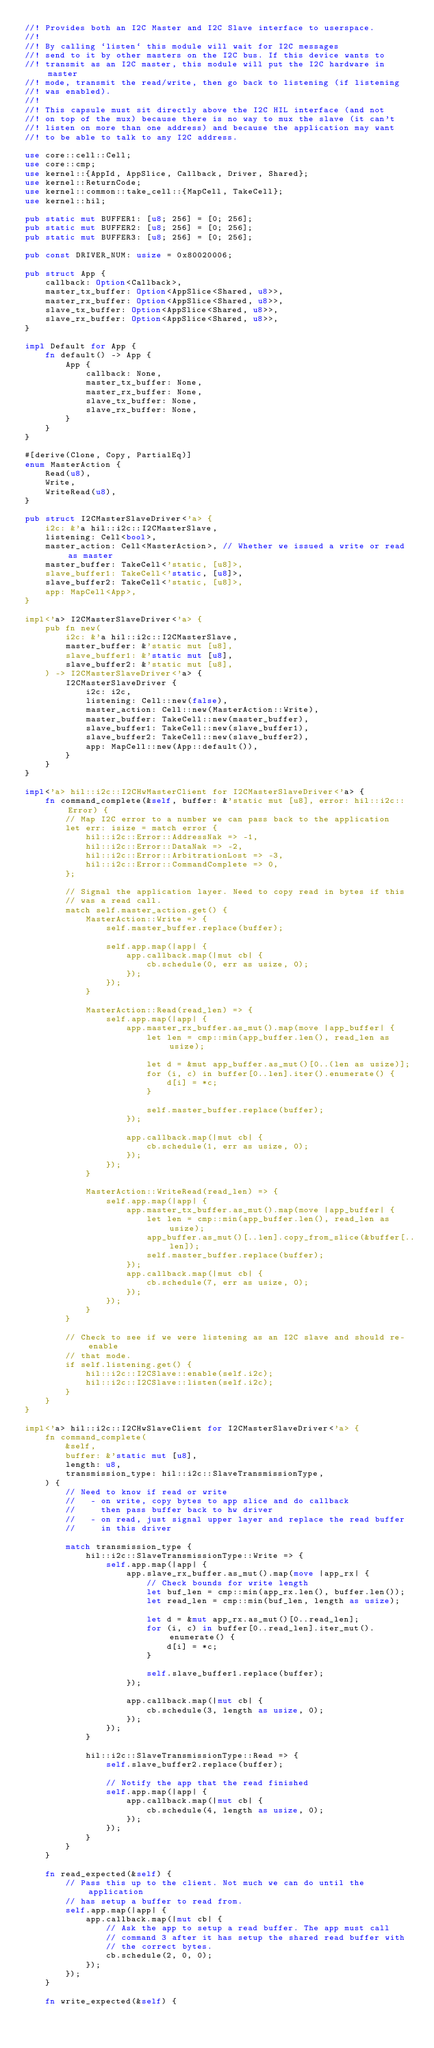Convert code to text. <code><loc_0><loc_0><loc_500><loc_500><_Rust_>//! Provides both an I2C Master and I2C Slave interface to userspace.
//!
//! By calling `listen` this module will wait for I2C messages
//! send to it by other masters on the I2C bus. If this device wants to
//! transmit as an I2C master, this module will put the I2C hardware in master
//! mode, transmit the read/write, then go back to listening (if listening
//! was enabled).
//!
//! This capsule must sit directly above the I2C HIL interface (and not
//! on top of the mux) because there is no way to mux the slave (it can't
//! listen on more than one address) and because the application may want
//! to be able to talk to any I2C address.

use core::cell::Cell;
use core::cmp;
use kernel::{AppId, AppSlice, Callback, Driver, Shared};
use kernel::ReturnCode;
use kernel::common::take_cell::{MapCell, TakeCell};
use kernel::hil;

pub static mut BUFFER1: [u8; 256] = [0; 256];
pub static mut BUFFER2: [u8; 256] = [0; 256];
pub static mut BUFFER3: [u8; 256] = [0; 256];

pub const DRIVER_NUM: usize = 0x80020006;

pub struct App {
    callback: Option<Callback>,
    master_tx_buffer: Option<AppSlice<Shared, u8>>,
    master_rx_buffer: Option<AppSlice<Shared, u8>>,
    slave_tx_buffer: Option<AppSlice<Shared, u8>>,
    slave_rx_buffer: Option<AppSlice<Shared, u8>>,
}

impl Default for App {
    fn default() -> App {
        App {
            callback: None,
            master_tx_buffer: None,
            master_rx_buffer: None,
            slave_tx_buffer: None,
            slave_rx_buffer: None,
        }
    }
}

#[derive(Clone, Copy, PartialEq)]
enum MasterAction {
    Read(u8),
    Write,
    WriteRead(u8),
}

pub struct I2CMasterSlaveDriver<'a> {
    i2c: &'a hil::i2c::I2CMasterSlave,
    listening: Cell<bool>,
    master_action: Cell<MasterAction>, // Whether we issued a write or read as master
    master_buffer: TakeCell<'static, [u8]>,
    slave_buffer1: TakeCell<'static, [u8]>,
    slave_buffer2: TakeCell<'static, [u8]>,
    app: MapCell<App>,
}

impl<'a> I2CMasterSlaveDriver<'a> {
    pub fn new(
        i2c: &'a hil::i2c::I2CMasterSlave,
        master_buffer: &'static mut [u8],
        slave_buffer1: &'static mut [u8],
        slave_buffer2: &'static mut [u8],
    ) -> I2CMasterSlaveDriver<'a> {
        I2CMasterSlaveDriver {
            i2c: i2c,
            listening: Cell::new(false),
            master_action: Cell::new(MasterAction::Write),
            master_buffer: TakeCell::new(master_buffer),
            slave_buffer1: TakeCell::new(slave_buffer1),
            slave_buffer2: TakeCell::new(slave_buffer2),
            app: MapCell::new(App::default()),
        }
    }
}

impl<'a> hil::i2c::I2CHwMasterClient for I2CMasterSlaveDriver<'a> {
    fn command_complete(&self, buffer: &'static mut [u8], error: hil::i2c::Error) {
        // Map I2C error to a number we can pass back to the application
        let err: isize = match error {
            hil::i2c::Error::AddressNak => -1,
            hil::i2c::Error::DataNak => -2,
            hil::i2c::Error::ArbitrationLost => -3,
            hil::i2c::Error::CommandComplete => 0,
        };

        // Signal the application layer. Need to copy read in bytes if this
        // was a read call.
        match self.master_action.get() {
            MasterAction::Write => {
                self.master_buffer.replace(buffer);

                self.app.map(|app| {
                    app.callback.map(|mut cb| {
                        cb.schedule(0, err as usize, 0);
                    });
                });
            }

            MasterAction::Read(read_len) => {
                self.app.map(|app| {
                    app.master_rx_buffer.as_mut().map(move |app_buffer| {
                        let len = cmp::min(app_buffer.len(), read_len as usize);

                        let d = &mut app_buffer.as_mut()[0..(len as usize)];
                        for (i, c) in buffer[0..len].iter().enumerate() {
                            d[i] = *c;
                        }

                        self.master_buffer.replace(buffer);
                    });

                    app.callback.map(|mut cb| {
                        cb.schedule(1, err as usize, 0);
                    });
                });
            }

            MasterAction::WriteRead(read_len) => {
                self.app.map(|app| {
                    app.master_tx_buffer.as_mut().map(move |app_buffer| {
                        let len = cmp::min(app_buffer.len(), read_len as usize);
                        app_buffer.as_mut()[..len].copy_from_slice(&buffer[..len]);
                        self.master_buffer.replace(buffer);
                    });
                    app.callback.map(|mut cb| {
                        cb.schedule(7, err as usize, 0);
                    });
                });
            }
        }

        // Check to see if we were listening as an I2C slave and should re-enable
        // that mode.
        if self.listening.get() {
            hil::i2c::I2CSlave::enable(self.i2c);
            hil::i2c::I2CSlave::listen(self.i2c);
        }
    }
}

impl<'a> hil::i2c::I2CHwSlaveClient for I2CMasterSlaveDriver<'a> {
    fn command_complete(
        &self,
        buffer: &'static mut [u8],
        length: u8,
        transmission_type: hil::i2c::SlaveTransmissionType,
    ) {
        // Need to know if read or write
        //   - on write, copy bytes to app slice and do callback
        //     then pass buffer back to hw driver
        //   - on read, just signal upper layer and replace the read buffer
        //     in this driver

        match transmission_type {
            hil::i2c::SlaveTransmissionType::Write => {
                self.app.map(|app| {
                    app.slave_rx_buffer.as_mut().map(move |app_rx| {
                        // Check bounds for write length
                        let buf_len = cmp::min(app_rx.len(), buffer.len());
                        let read_len = cmp::min(buf_len, length as usize);

                        let d = &mut app_rx.as_mut()[0..read_len];
                        for (i, c) in buffer[0..read_len].iter_mut().enumerate() {
                            d[i] = *c;
                        }

                        self.slave_buffer1.replace(buffer);
                    });

                    app.callback.map(|mut cb| {
                        cb.schedule(3, length as usize, 0);
                    });
                });
            }

            hil::i2c::SlaveTransmissionType::Read => {
                self.slave_buffer2.replace(buffer);

                // Notify the app that the read finished
                self.app.map(|app| {
                    app.callback.map(|mut cb| {
                        cb.schedule(4, length as usize, 0);
                    });
                });
            }
        }
    }

    fn read_expected(&self) {
        // Pass this up to the client. Not much we can do until the application
        // has setup a buffer to read from.
        self.app.map(|app| {
            app.callback.map(|mut cb| {
                // Ask the app to setup a read buffer. The app must call
                // command 3 after it has setup the shared read buffer with
                // the correct bytes.
                cb.schedule(2, 0, 0);
            });
        });
    }

    fn write_expected(&self) {</code> 